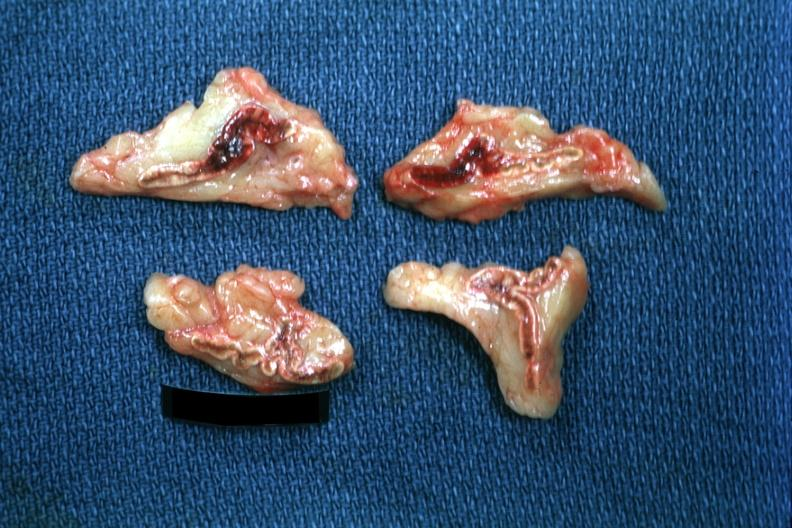what is present?
Answer the question using a single word or phrase. Adrenal 